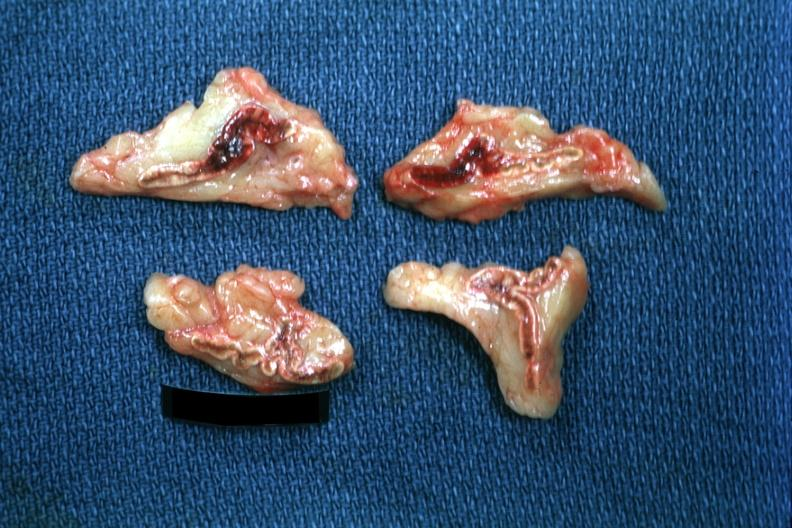what is present?
Answer the question using a single word or phrase. Adrenal 